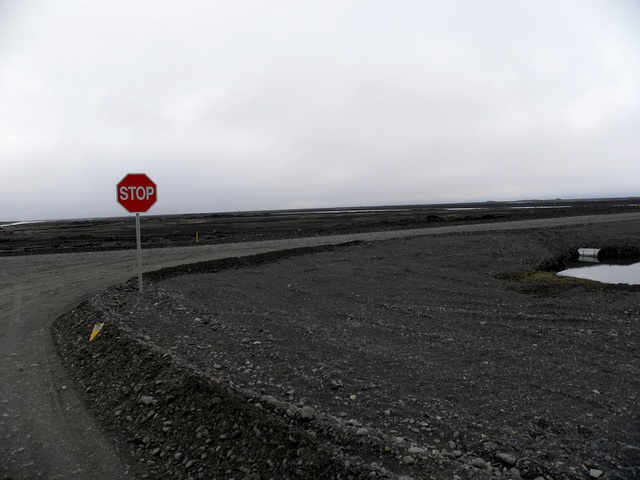Describe the objects in this image and their specific colors. I can see a stop sign in lightgray, maroon, gray, and darkgray tones in this image. 